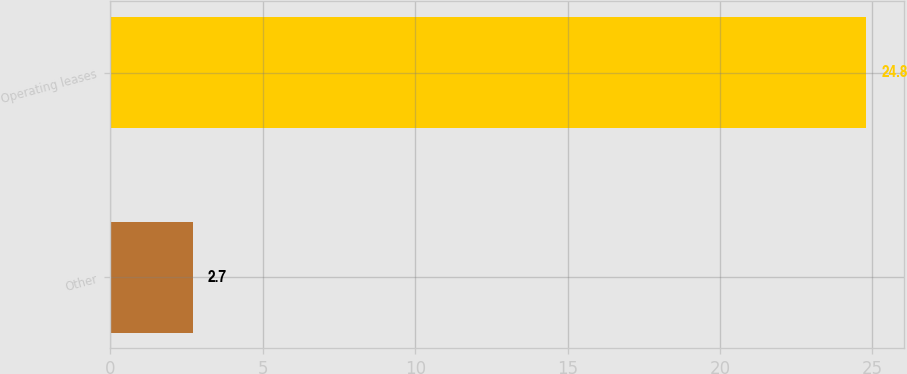Convert chart to OTSL. <chart><loc_0><loc_0><loc_500><loc_500><bar_chart><fcel>Other<fcel>Operating leases<nl><fcel>2.7<fcel>24.8<nl></chart> 